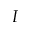Convert formula to latex. <formula><loc_0><loc_0><loc_500><loc_500>I</formula> 